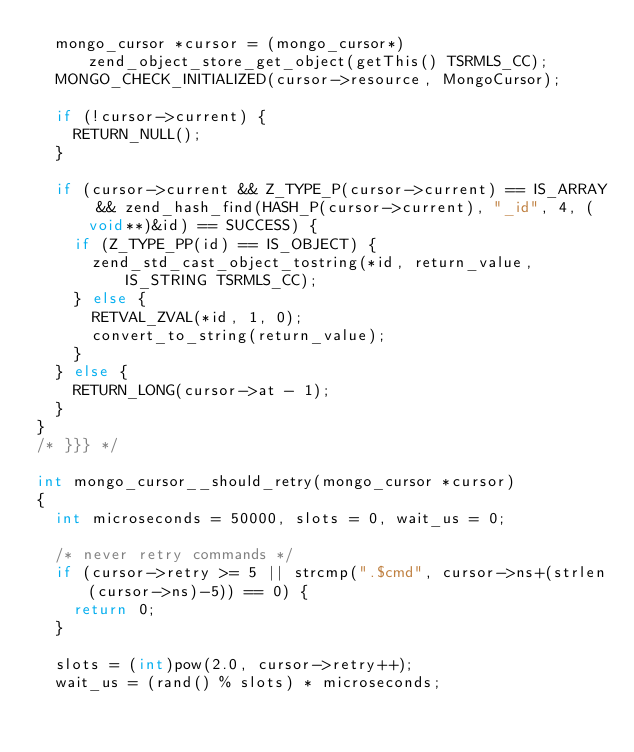<code> <loc_0><loc_0><loc_500><loc_500><_C++_>	mongo_cursor *cursor = (mongo_cursor*)zend_object_store_get_object(getThis() TSRMLS_CC);
	MONGO_CHECK_INITIALIZED(cursor->resource, MongoCursor);

	if (!cursor->current) {
		RETURN_NULL();
	}

	if (cursor->current && Z_TYPE_P(cursor->current) == IS_ARRAY && zend_hash_find(HASH_P(cursor->current), "_id", 4, (void**)&id) == SUCCESS) {
		if (Z_TYPE_PP(id) == IS_OBJECT) {
			zend_std_cast_object_tostring(*id, return_value, IS_STRING TSRMLS_CC);
		} else {
			RETVAL_ZVAL(*id, 1, 0);
			convert_to_string(return_value);
		}
	} else {
		RETURN_LONG(cursor->at - 1);
	}
}
/* }}} */

int mongo_cursor__should_retry(mongo_cursor *cursor)
{
	int microseconds = 50000, slots = 0, wait_us = 0;

	/* never retry commands */
	if (cursor->retry >= 5 || strcmp(".$cmd", cursor->ns+(strlen(cursor->ns)-5)) == 0) {
		return 0;
	}

	slots = (int)pow(2.0, cursor->retry++);
	wait_us = (rand() % slots) * microseconds;
</code> 